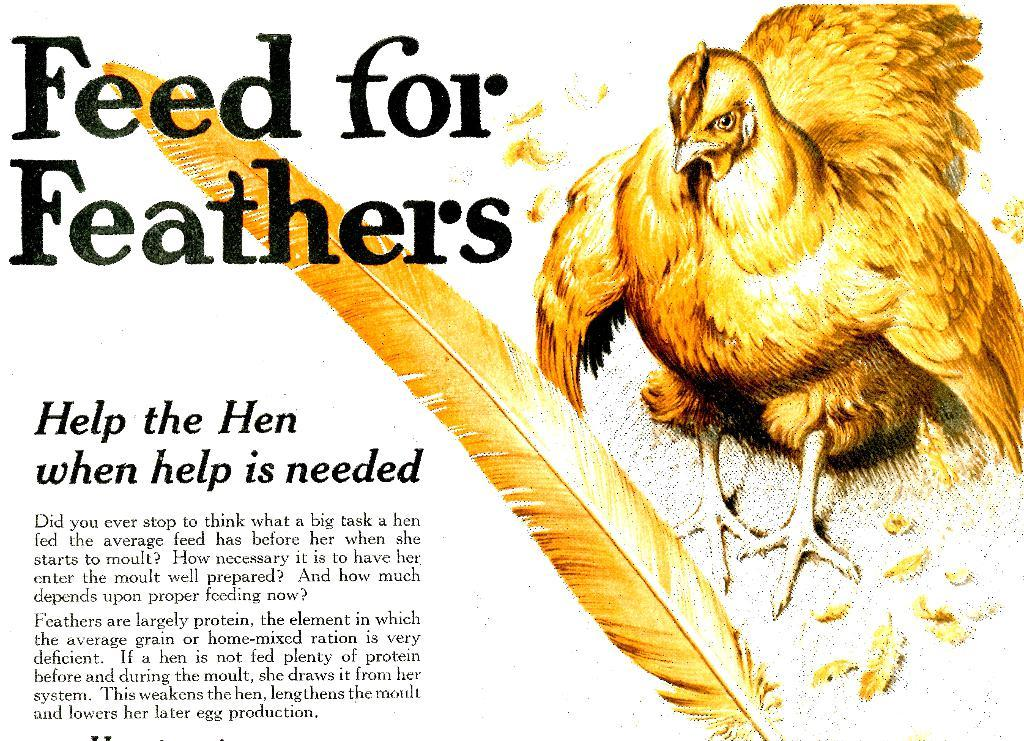What type of animal is in the image? There is a yellow color bird in the image. What physical features does the bird have? The bird has feathers. Is there any text or markings on the bird? Yes, there is something written on the bird, likely in black color. What is the color of the background in the image? The background of the image is white. How many mice are hiding behind the bird in the image? There are no mice present in the image; it only features a yellow color bird. What type of bread is being used to feed the bird in the image? There is no bread visible in the image, and the bird is not being fed in the image. 